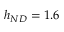<formula> <loc_0><loc_0><loc_500><loc_500>h _ { N D } = 1 . 6</formula> 